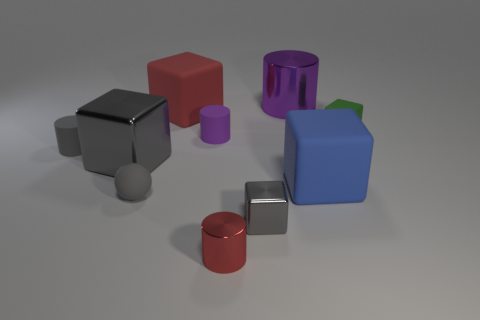Subtract all green blocks. How many blocks are left? 4 Subtract all small gray blocks. How many blocks are left? 4 Subtract all brown cylinders. Subtract all blue cubes. How many cylinders are left? 4 Subtract all cylinders. How many objects are left? 6 Subtract all small purple rubber cylinders. Subtract all rubber balls. How many objects are left? 8 Add 1 red cylinders. How many red cylinders are left? 2 Add 2 big blue matte blocks. How many big blue matte blocks exist? 3 Subtract 2 purple cylinders. How many objects are left? 8 